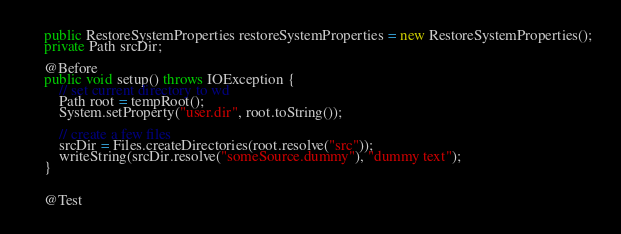Convert code to text. <code><loc_0><loc_0><loc_500><loc_500><_Java_>    public RestoreSystemProperties restoreSystemProperties = new RestoreSystemProperties();
    private Path srcDir;

    @Before
    public void setup() throws IOException {
        // set current directory to wd
        Path root = tempRoot();
        System.setProperty("user.dir", root.toString());

        // create a few files
        srcDir = Files.createDirectories(root.resolve("src"));
        writeString(srcDir.resolve("someSource.dummy"), "dummy text");
    }


    @Test</code> 